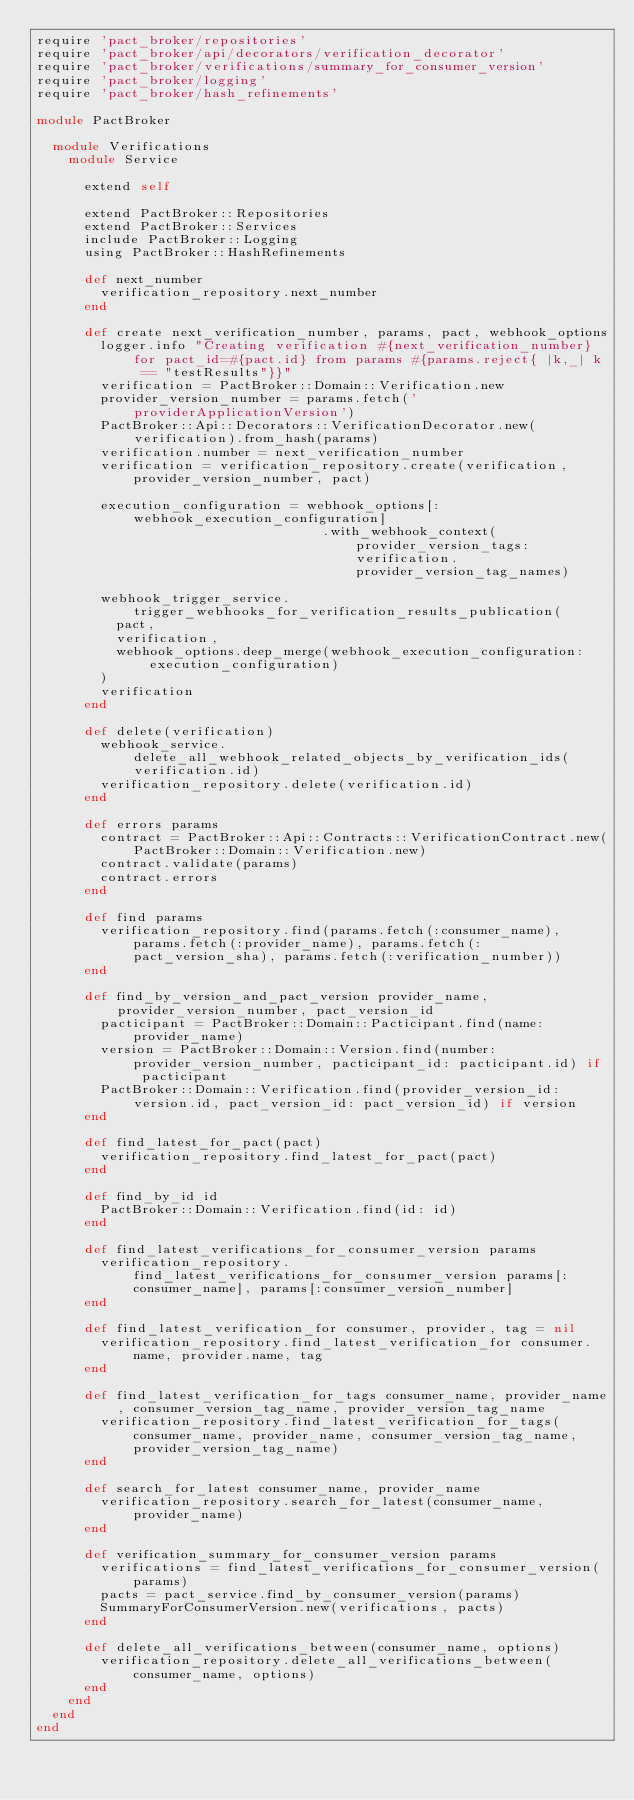Convert code to text. <code><loc_0><loc_0><loc_500><loc_500><_Ruby_>require 'pact_broker/repositories'
require 'pact_broker/api/decorators/verification_decorator'
require 'pact_broker/verifications/summary_for_consumer_version'
require 'pact_broker/logging'
require 'pact_broker/hash_refinements'

module PactBroker

  module Verifications
    module Service

      extend self

      extend PactBroker::Repositories
      extend PactBroker::Services
      include PactBroker::Logging
      using PactBroker::HashRefinements

      def next_number
        verification_repository.next_number
      end

      def create next_verification_number, params, pact, webhook_options
        logger.info "Creating verification #{next_verification_number} for pact_id=#{pact.id} from params #{params.reject{ |k,_| k == "testResults"}}"
        verification = PactBroker::Domain::Verification.new
        provider_version_number = params.fetch('providerApplicationVersion')
        PactBroker::Api::Decorators::VerificationDecorator.new(verification).from_hash(params)
        verification.number = next_verification_number
        verification = verification_repository.create(verification, provider_version_number, pact)

        execution_configuration = webhook_options[:webhook_execution_configuration]
                                    .with_webhook_context(provider_version_tags: verification.provider_version_tag_names)

        webhook_trigger_service.trigger_webhooks_for_verification_results_publication(
          pact,
          verification,
          webhook_options.deep_merge(webhook_execution_configuration: execution_configuration)
        )
        verification
      end

      def delete(verification)
        webhook_service.delete_all_webhook_related_objects_by_verification_ids(verification.id)
        verification_repository.delete(verification.id)
      end

      def errors params
        contract = PactBroker::Api::Contracts::VerificationContract.new(PactBroker::Domain::Verification.new)
        contract.validate(params)
        contract.errors
      end

      def find params
        verification_repository.find(params.fetch(:consumer_name), params.fetch(:provider_name), params.fetch(:pact_version_sha), params.fetch(:verification_number))
      end

      def find_by_version_and_pact_version provider_name, provider_version_number, pact_version_id
        pacticipant = PactBroker::Domain::Pacticipant.find(name: provider_name)
        version = PactBroker::Domain::Version.find(number: provider_version_number, pacticipant_id: pacticipant.id) if pacticipant
        PactBroker::Domain::Verification.find(provider_version_id: version.id, pact_version_id: pact_version_id) if version
      end

      def find_latest_for_pact(pact)
        verification_repository.find_latest_for_pact(pact)
      end

      def find_by_id id
        PactBroker::Domain::Verification.find(id: id)
      end

      def find_latest_verifications_for_consumer_version params
        verification_repository.find_latest_verifications_for_consumer_version params[:consumer_name], params[:consumer_version_number]
      end

      def find_latest_verification_for consumer, provider, tag = nil
        verification_repository.find_latest_verification_for consumer.name, provider.name, tag
      end

      def find_latest_verification_for_tags consumer_name, provider_name, consumer_version_tag_name, provider_version_tag_name
        verification_repository.find_latest_verification_for_tags(consumer_name, provider_name, consumer_version_tag_name, provider_version_tag_name)
      end

      def search_for_latest consumer_name, provider_name
        verification_repository.search_for_latest(consumer_name, provider_name)
      end

      def verification_summary_for_consumer_version params
        verifications = find_latest_verifications_for_consumer_version(params)
        pacts = pact_service.find_by_consumer_version(params)
        SummaryForConsumerVersion.new(verifications, pacts)
      end

      def delete_all_verifications_between(consumer_name, options)
        verification_repository.delete_all_verifications_between(consumer_name, options)
      end
    end
  end
end
</code> 